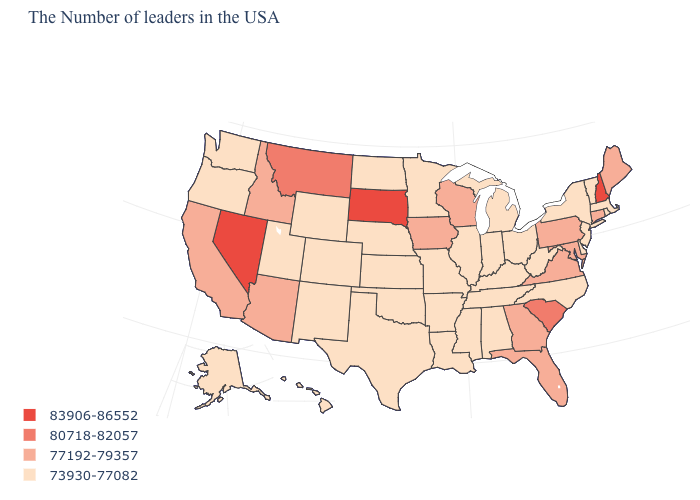Does the first symbol in the legend represent the smallest category?
Be succinct. No. Among the states that border Idaho , does Wyoming have the lowest value?
Answer briefly. Yes. Which states hav the highest value in the West?
Write a very short answer. Nevada. Name the states that have a value in the range 73930-77082?
Write a very short answer. Massachusetts, Rhode Island, Vermont, New York, New Jersey, Delaware, North Carolina, West Virginia, Ohio, Michigan, Kentucky, Indiana, Alabama, Tennessee, Illinois, Mississippi, Louisiana, Missouri, Arkansas, Minnesota, Kansas, Nebraska, Oklahoma, Texas, North Dakota, Wyoming, Colorado, New Mexico, Utah, Washington, Oregon, Alaska, Hawaii. Which states have the highest value in the USA?
Write a very short answer. New Hampshire, South Dakota, Nevada. What is the lowest value in states that border Vermont?
Write a very short answer. 73930-77082. Name the states that have a value in the range 80718-82057?
Answer briefly. South Carolina, Montana. Name the states that have a value in the range 83906-86552?
Write a very short answer. New Hampshire, South Dakota, Nevada. Name the states that have a value in the range 73930-77082?
Give a very brief answer. Massachusetts, Rhode Island, Vermont, New York, New Jersey, Delaware, North Carolina, West Virginia, Ohio, Michigan, Kentucky, Indiana, Alabama, Tennessee, Illinois, Mississippi, Louisiana, Missouri, Arkansas, Minnesota, Kansas, Nebraska, Oklahoma, Texas, North Dakota, Wyoming, Colorado, New Mexico, Utah, Washington, Oregon, Alaska, Hawaii. What is the lowest value in states that border Arizona?
Short answer required. 73930-77082. Among the states that border North Carolina , does Tennessee have the highest value?
Write a very short answer. No. Does South Dakota have the highest value in the USA?
Quick response, please. Yes. Which states have the highest value in the USA?
Concise answer only. New Hampshire, South Dakota, Nevada. Name the states that have a value in the range 80718-82057?
Short answer required. South Carolina, Montana. Does Nevada have the highest value in the West?
Concise answer only. Yes. 